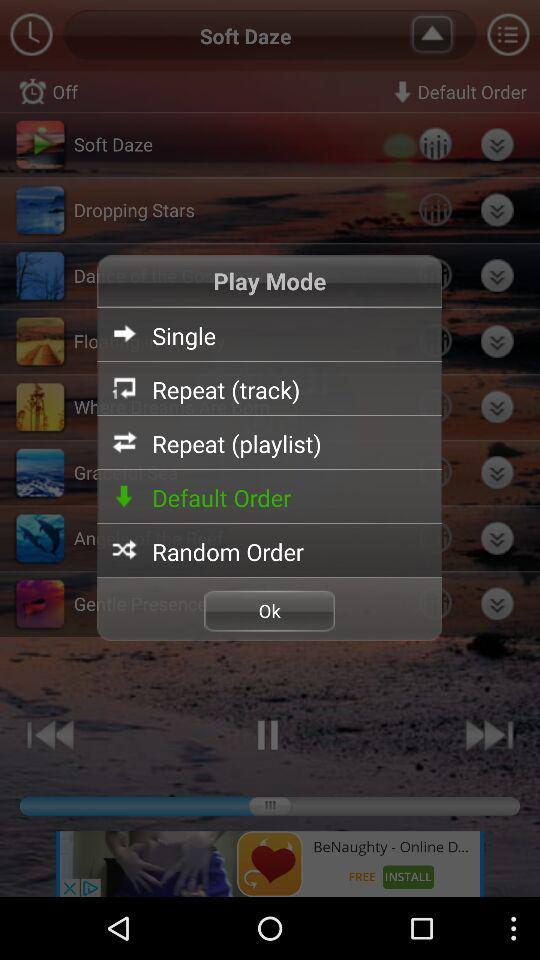What is the volume percentage of the "Paddling"? The volume percentage of the "Paddling" is 30. 